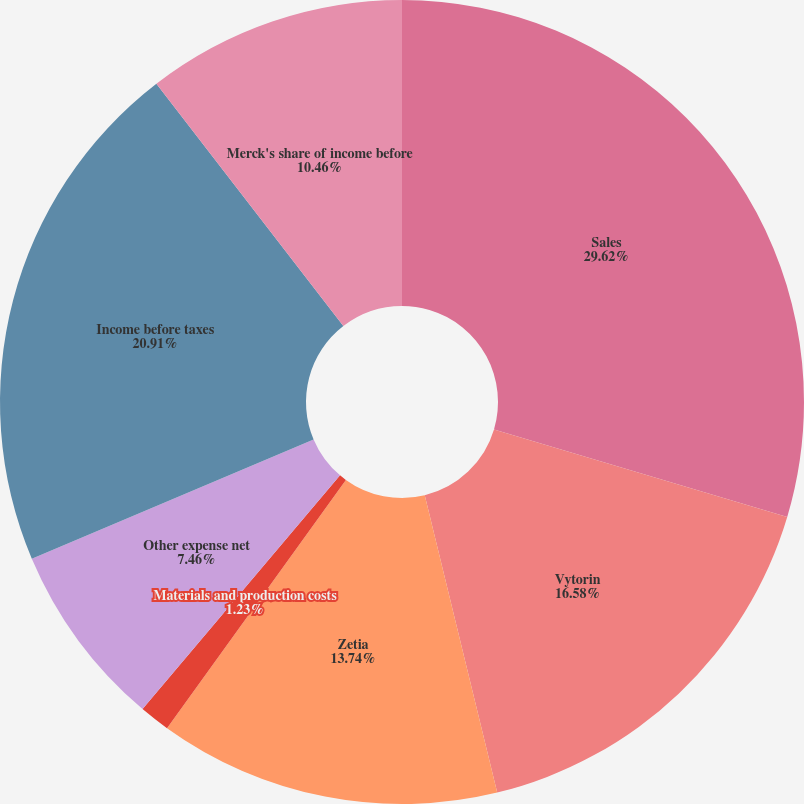<chart> <loc_0><loc_0><loc_500><loc_500><pie_chart><fcel>Sales<fcel>Vytorin<fcel>Zetia<fcel>Materials and production costs<fcel>Other expense net<fcel>Income before taxes<fcel>Merck's share of income before<nl><fcel>29.61%<fcel>16.58%<fcel>13.74%<fcel>1.23%<fcel>7.46%<fcel>20.91%<fcel>10.46%<nl></chart> 